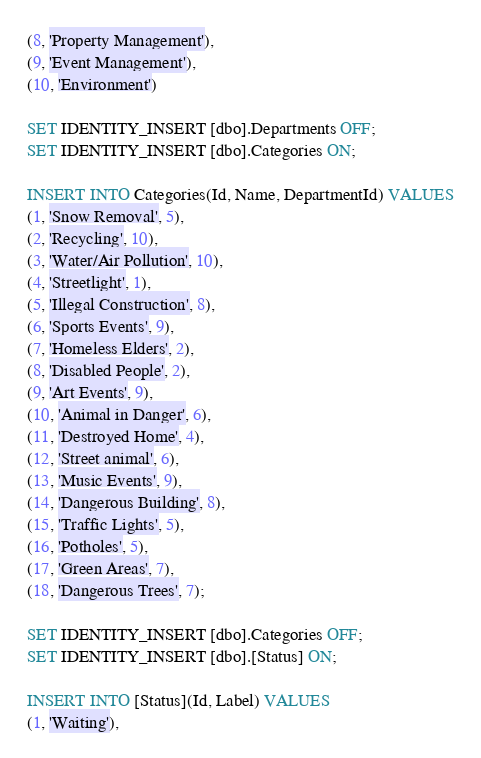Convert code to text. <code><loc_0><loc_0><loc_500><loc_500><_SQL_>(8, 'Property Management'), 
(9, 'Event Management'), 
(10, 'Environment')

SET IDENTITY_INSERT [dbo].Departments OFF;
SET IDENTITY_INSERT [dbo].Categories ON;

INSERT INTO Categories(Id, Name, DepartmentId) VALUES
(1, 'Snow Removal', 5), 
(2, 'Recycling', 10),
(3, 'Water/Air Pollution', 10), 
(4, 'Streetlight', 1),
(5, 'Illegal Construction', 8),
(6, 'Sports Events', 9), 
(7, 'Homeless Elders', 2), 
(8, 'Disabled People', 2), 
(9, 'Art Events', 9),
(10, 'Animal in Danger', 6), 
(11, 'Destroyed Home', 4), 
(12, 'Street animal', 6),
(13, 'Music Events', 9),
(14, 'Dangerous Building', 8),
(15, 'Traffic Lights', 5), 
(16, 'Potholes', 5), 
(17, 'Green Areas', 7), 
(18, 'Dangerous Trees', 7);

SET IDENTITY_INSERT [dbo].Categories OFF;
SET IDENTITY_INSERT [dbo].[Status] ON;

INSERT INTO [Status](Id, Label) VALUES
(1, 'Waiting'), </code> 